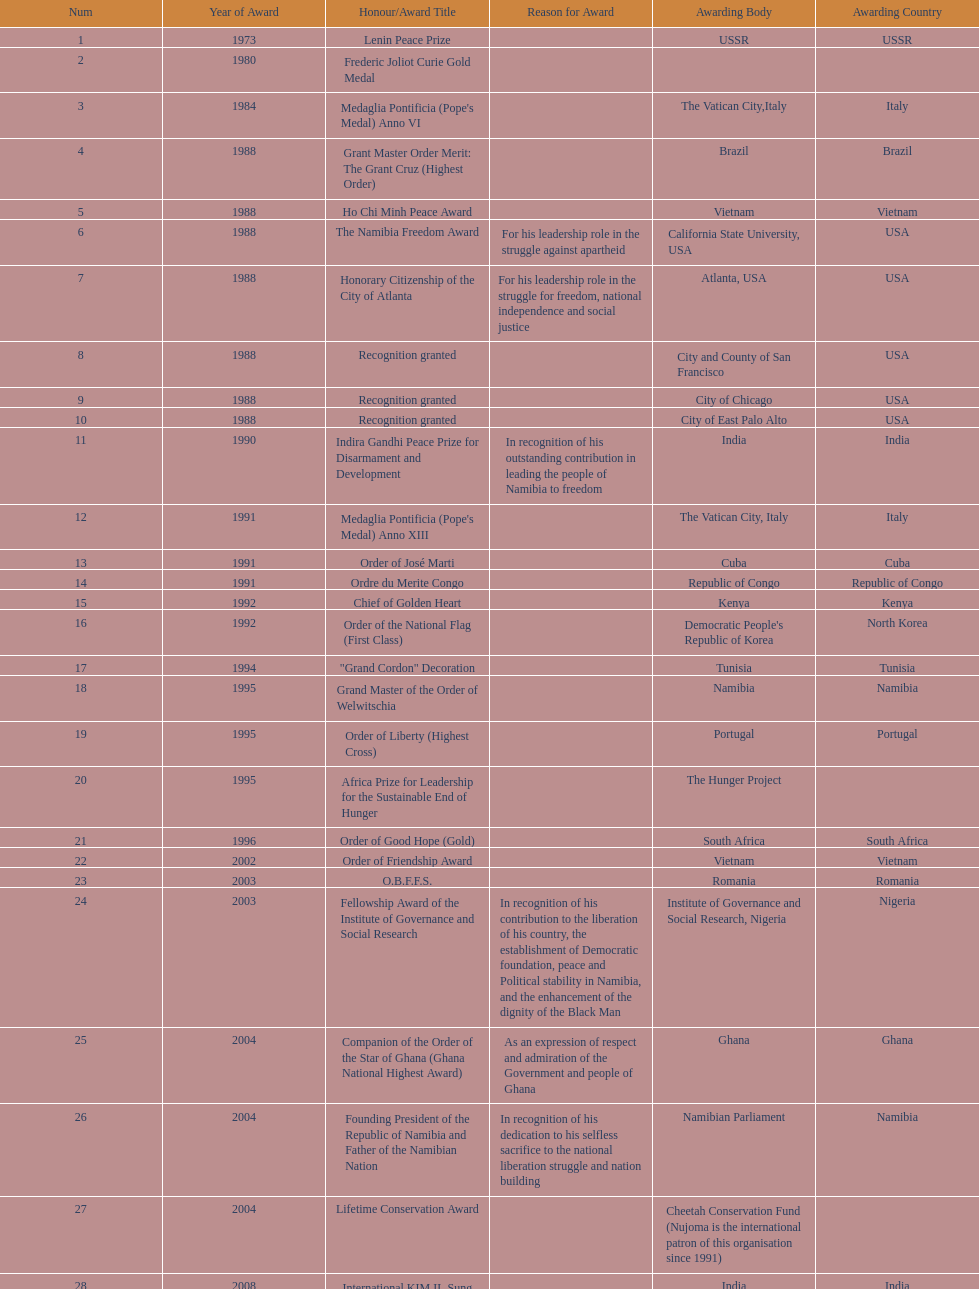Parse the full table. {'header': ['Num', 'Year of Award', 'Honour/Award Title', 'Reason for Award', 'Awarding Body', 'Awarding Country'], 'rows': [['1', '1973', 'Lenin Peace Prize', '', 'USSR', 'USSR'], ['2', '1980', 'Frederic Joliot Curie Gold Medal', '', '', ''], ['3', '1984', "Medaglia Pontificia (Pope's Medal) Anno VI", '', 'The Vatican City,Italy', 'Italy'], ['4', '1988', 'Grant Master Order Merit: The Grant Cruz (Highest Order)', '', 'Brazil', 'Brazil'], ['5', '1988', 'Ho Chi Minh Peace Award', '', 'Vietnam', 'Vietnam'], ['6', '1988', 'The Namibia Freedom Award', 'For his leadership role in the struggle against apartheid', 'California State University, USA', 'USA'], ['7', '1988', 'Honorary Citizenship of the City of Atlanta', 'For his leadership role in the struggle for freedom, national independence and social justice', 'Atlanta, USA', 'USA'], ['8', '1988', 'Recognition granted', '', 'City and County of San Francisco', 'USA'], ['9', '1988', 'Recognition granted', '', 'City of Chicago', 'USA'], ['10', '1988', 'Recognition granted', '', 'City of East Palo Alto', 'USA'], ['11', '1990', 'Indira Gandhi Peace Prize for Disarmament and Development', 'In recognition of his outstanding contribution in leading the people of Namibia to freedom', 'India', 'India'], ['12', '1991', "Medaglia Pontificia (Pope's Medal) Anno XIII", '', 'The Vatican City, Italy', 'Italy'], ['13', '1991', 'Order of José Marti', '', 'Cuba', 'Cuba'], ['14', '1991', 'Ordre du Merite Congo', '', 'Republic of Congo', 'Republic of Congo'], ['15', '1992', 'Chief of Golden Heart', '', 'Kenya', 'Kenya'], ['16', '1992', 'Order of the National Flag (First Class)', '', "Democratic People's Republic of Korea", 'North Korea'], ['17', '1994', '"Grand Cordon" Decoration', '', 'Tunisia', 'Tunisia'], ['18', '1995', 'Grand Master of the Order of Welwitschia', '', 'Namibia', 'Namibia'], ['19', '1995', 'Order of Liberty (Highest Cross)', '', 'Portugal', 'Portugal'], ['20', '1995', 'Africa Prize for Leadership for the Sustainable End of Hunger', '', 'The Hunger Project', ''], ['21', '1996', 'Order of Good Hope (Gold)', '', 'South Africa', 'South Africa'], ['22', '2002', 'Order of Friendship Award', '', 'Vietnam', 'Vietnam'], ['23', '2003', 'O.B.F.F.S.', '', 'Romania', 'Romania'], ['24', '2003', 'Fellowship Award of the Institute of Governance and Social Research', 'In recognition of his contribution to the liberation of his country, the establishment of Democratic foundation, peace and Political stability in Namibia, and the enhancement of the dignity of the Black Man', 'Institute of Governance and Social Research, Nigeria', 'Nigeria'], ['25', '2004', 'Companion of the Order of the Star of Ghana (Ghana National Highest Award)', 'As an expression of respect and admiration of the Government and people of Ghana', 'Ghana', 'Ghana'], ['26', '2004', 'Founding President of the Republic of Namibia and Father of the Namibian Nation', 'In recognition of his dedication to his selfless sacrifice to the national liberation struggle and nation building', 'Namibian Parliament', 'Namibia'], ['27', '2004', 'Lifetime Conservation Award', '', 'Cheetah Conservation Fund (Nujoma is the international patron of this organisation since 1991)', ''], ['28', '2008', 'International KIM IL Sung Prize Certificate', '', 'India', 'India'], ['29', '2010', 'Sir Seretse Khama SADC Meda', '', 'SADC', '']]} What is the total number of awards that nujoma won? 29. 